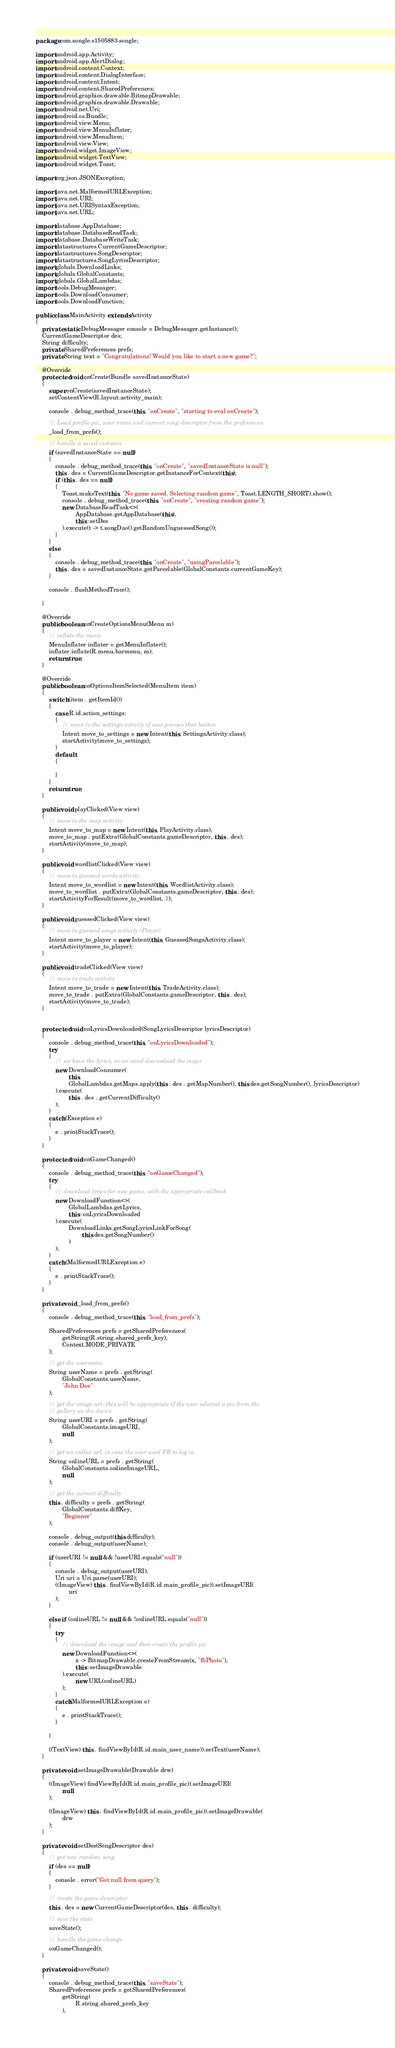Convert code to text. <code><loc_0><loc_0><loc_500><loc_500><_Java_>package com.songle.s1505883.songle;

import android.app.Activity;
import android.app.AlertDialog;
import android.content.Context;
import android.content.DialogInterface;
import android.content.Intent;
import android.content.SharedPreferences;
import android.graphics.drawable.BitmapDrawable;
import android.graphics.drawable.Drawable;
import android.net.Uri;
import android.os.Bundle;
import android.view.Menu;
import android.view.MenuInflater;
import android.view.MenuItem;
import android.view.View;
import android.widget.ImageView;
import android.widget.TextView;
import android.widget.Toast;

import org.json.JSONException;

import java.net.MalformedURLException;
import java.net.URI;
import java.net.URISyntaxException;
import java.net.URL;

import database.AppDatabase;
import database.DatabaseReadTask;
import database.DatabaseWriteTask;
import datastructures.CurrentGameDescriptor;
import datastructures.SongDescriptor;
import datastructures.SongLyricsDescriptor;
import globals.DownloadLinks;
import globals.GlobalConstants;
import globals.GlobalLambdas;
import tools.DebugMessager;
import tools.DownloadConsumer;
import tools.DownloadFunction;

public class MainActivity extends Activity
{
    private static DebugMessager console = DebugMessager.getInstance();
    CurrentGameDescriptor des;
    String difficulty;
    private SharedPreferences prefs;
    private String text = "Congratulations! Would you like to start a new game?";

    @Override
    protected void onCreate(Bundle savedInstanceState)
    {
        super.onCreate(savedInstanceState);
        setContentView(R.layout.activity_main);

        console . debug_method_trace(this, "onCreate", "starting to eval onCreate");

        // Load profile pic, user name and current song descriptor from the preferences
        _load_from_prefs();

        // handle a saved instance
        if (savedInstanceState == null)
        {
            console . debug_method_trace(this, "onCreate", "savedInstanceState is null");
            this . des = CurrentGameDescriptor.getInstanceForContext(this);
            if (this . des == null)
            {
                Toast.makeText(this, "No game saved. Selecting random game", Toast.LENGTH_SHORT).show();
                console . debug_method_trace(this, "onCreate", "creating random game");
                new DatabaseReadTask<>(
                        AppDatabase.getAppDatabase(this),
                        this::setDes
                ).execute(t -> t.songDao().getRandomUnguessedSong());
            }
        }
        else
        {
            console . debug_method_trace(this, "onCreate", "usingParcelable");
            this . des = savedInstanceState.getParcelable(GlobalConstants.currentGameKey);
        }

        console . flushMethodTrace();

    }

    @Override
    public boolean onCreateOptionsMenu(Menu m)
    {
        // inflate the menu
        MenuInflater inflater = getMenuInflater();
        inflater.inflate(R.menu.barmenu, m);
        return true;
    }

    @Override
    public boolean onOptionsItemSelected(MenuItem item)
    {
        switch (item . getItemId())
        {
            case R.id.action_settings:
            {
                // move to the settings activity if user presses that button
                Intent move_to_settings = new Intent(this, SettingsActivity.class);
                startActivity(move_to_settings);
            }
            default:
            {

            }
        }
        return true;
    }

    public void playClicked(View view)
    {
        // move to the map activity
        Intent move_to_map = new Intent(this, PlayActivity.class);
        move_to_map . putExtra(GlobalConstants.gameDescriptor, this . des);
        startActivity(move_to_map);
    }

    public void wordlistClicked(View view)
    {
        // move to guessed words activity
        Intent move_to_wordlist = new Intent(this, WordlistActivity.class);
        move_to_wordlist . putExtra(GlobalConstants.gameDescriptor, this . des);
        startActivityForResult(move_to_wordlist, 1);
    }

    public void guessedClicked(View view)
    {
        // move to guessed songs activity (Player)
        Intent move_to_player = new Intent(this, GuessedSongsActivity.class);
        startActivity(move_to_player);
    }

    public void tradeClicked(View view)
    {
        // move to trade activity
        Intent move_to_trade = new Intent(this, TradeActivity.class);
        move_to_trade . putExtra(GlobalConstants.gameDescriptor, this . des);
        startActivity(move_to_trade);
    }


    protected void onLyricsDownloaded(SongLyricsDescriptor lyricsDescriptor)
    {
        console . debug_method_trace(this, "onLyricsDownloaded");
        try
        {
            // we have the lyrics, so we cand downaload the maps
            new DownloadConsumer(
                    this,
                    GlobalLambdas.getMaps.apply(this . des . getMapNumber(), this.des.getSongNumber(), lyricsDescriptor)
            ).execute(
                    this . des . getCurrentDifficulty()
            );
        }
        catch (Exception e)
        {
            e . printStackTrace();
        }
    }

    protected void onGameChanged()
    {
        console . debug_method_trace(this, "onGameChanged");
        try
        {
            // download lyrics for new game, with the appropriate callback
            new DownloadFunction<>(
                    GlobalLambdas.getLyrics,
                    this::onLyricsDownloaded
            ).execute(
                    DownloadLinks.getSongLyricsLinkForSong(
                            this.des.getSongNumber()
                    )
            );
        }
        catch (MalformedURLException e)
        {
            e . printStackTrace();
        }
    }

    private void _load_from_prefs()
    {
        console . debug_method_trace(this, "load_from_prefs");

        SharedPreferences prefs = getSharedPreferences(
                getString(R.string.shared_prefs_key),
                Context.MODE_PRIVATE
        );

        // get the username
        String userName = prefs . getString(
                GlobalConstants.userName,
                "John Doe"
        );

        // get the image uri. this will be appropriate if the user selected a pic from the
        // gallery on the device
        String userURI = prefs . getString(
                GlobalConstants.imageURI,
                null
        );

        // get an online url, in case the user used FB to log in
        String onlineURL = prefs . getString(
                GlobalConstants.onlineImageURL,
                null
        );

        // get the current difficulty
        this . difficulty = prefs . getString(
                GlobalConstants.diffKey,
                "Beginner"
        );

        console . debug_output(this.difficulty);
        console . debug_output(userName);

        if (userURI != null && !userURI.equals("null"))
        {
            console . debug_output(userURI);
            Uri uri = Uri.parse(userURI);
            ((ImageView) this . findViewById(R.id.main_profile_pic)).setImageURI(
                    uri
            );
        }

        else if (onlineURL != null && !onlineURL.equals("null"))
        {
            try
            {
                // download the image and then create the profile pic
                new DownloadFunction<>(
                        x -> BitmapDrawable.createFromStream(x, "fbPhoto"),
                        this::setImageDrawable
                ).execute(
                        new URL(onlineURL)
                );
            }
            catch(MalformedURLException e)
            {
                e . printStackTrace();
            }

        }

        ((TextView) this . findViewById(R.id.main_user_name)).setText(userName);
    }

    private void setImageDrawable(Drawable drw)
    {
        ((ImageView) findViewById(R.id.main_profile_pic)).setImageURI(
                null
        );

        ((ImageView) this . findViewById(R.id.main_profile_pic)).setImageDrawable(
                drw
        );
    }

    private void setDes(SongDescriptor des)
    {
        // got new random song
        if (des == null)
        {
            console . error("Got null from query");
        }

        // create the game descriptor
        this . des = new CurrentGameDescriptor(des, this . difficulty);

        // save the state
        saveState();

        // handle the game change
        onGameChanged();
    }

    private void saveState()
    {
        console . debug_method_trace(this, "saveState");
        SharedPreferences prefs = getSharedPreferences(
                getString(
                        R.string.shared_prefs_key
                ),</code> 